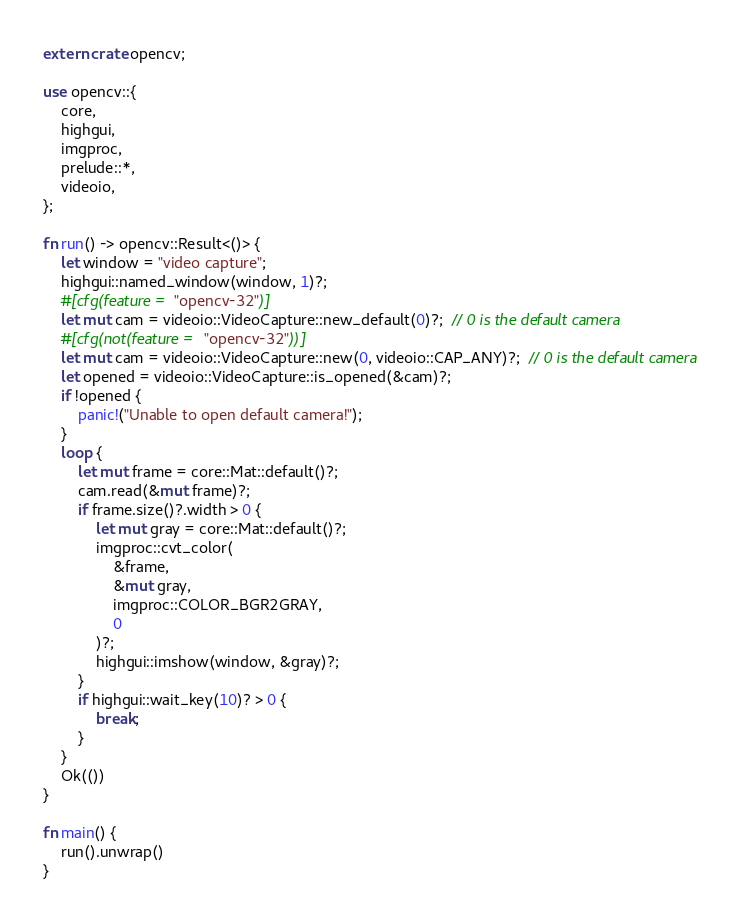Convert code to text. <code><loc_0><loc_0><loc_500><loc_500><_Rust_>extern crate opencv;

use opencv::{
    core,
    highgui,
    imgproc,
    prelude::*,
    videoio,
};

fn run() -> opencv::Result<()> {
    let window = "video capture";
    highgui::named_window(window, 1)?;
    #[cfg(feature = "opencv-32")]
    let mut cam = videoio::VideoCapture::new_default(0)?;  // 0 is the default camera
    #[cfg(not(feature = "opencv-32"))]
    let mut cam = videoio::VideoCapture::new(0, videoio::CAP_ANY)?;  // 0 is the default camera
    let opened = videoio::VideoCapture::is_opened(&cam)?;
    if !opened {
        panic!("Unable to open default camera!");
    }
    loop {
        let mut frame = core::Mat::default()?;
        cam.read(&mut frame)?;
        if frame.size()?.width > 0 {
            let mut gray = core::Mat::default()?;
            imgproc::cvt_color(
                &frame,
                &mut gray,
                imgproc::COLOR_BGR2GRAY,
                0
            )?;
            highgui::imshow(window, &gray)?;
        }
        if highgui::wait_key(10)? > 0 {
            break;
        }
    }
    Ok(())
}

fn main() {
    run().unwrap()
}
</code> 